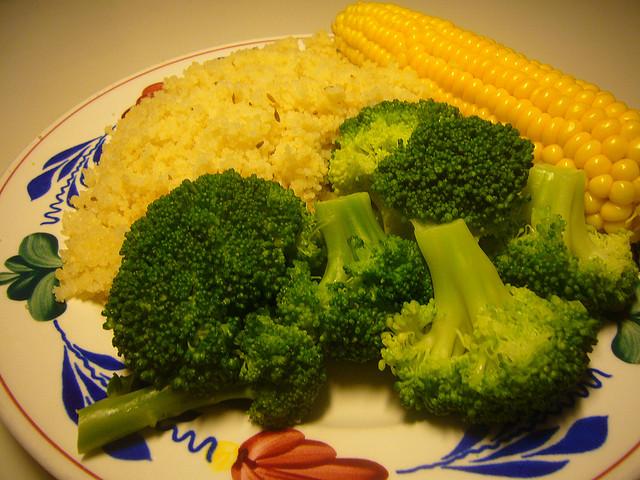What is the green food on the plate?
Keep it brief. Broccoli. What vegetable dominates the plate?
Concise answer only. Broccoli. Is this meal vegetarian?
Write a very short answer. Yes. 